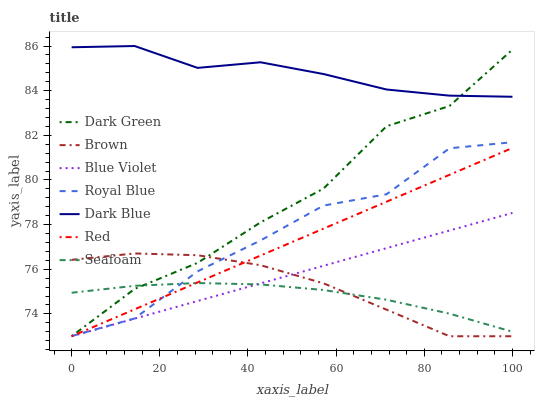Does Seafoam have the minimum area under the curve?
Answer yes or no. Yes. Does Dark Blue have the maximum area under the curve?
Answer yes or no. Yes. Does Dark Blue have the minimum area under the curve?
Answer yes or no. No. Does Seafoam have the maximum area under the curve?
Answer yes or no. No. Is Red the smoothest?
Answer yes or no. Yes. Is Dark Green the roughest?
Answer yes or no. Yes. Is Dark Blue the smoothest?
Answer yes or no. No. Is Dark Blue the roughest?
Answer yes or no. No. Does Brown have the lowest value?
Answer yes or no. Yes. Does Seafoam have the lowest value?
Answer yes or no. No. Does Dark Blue have the highest value?
Answer yes or no. Yes. Does Seafoam have the highest value?
Answer yes or no. No. Is Brown less than Dark Blue?
Answer yes or no. Yes. Is Dark Blue greater than Brown?
Answer yes or no. Yes. Does Dark Green intersect Royal Blue?
Answer yes or no. Yes. Is Dark Green less than Royal Blue?
Answer yes or no. No. Is Dark Green greater than Royal Blue?
Answer yes or no. No. Does Brown intersect Dark Blue?
Answer yes or no. No. 